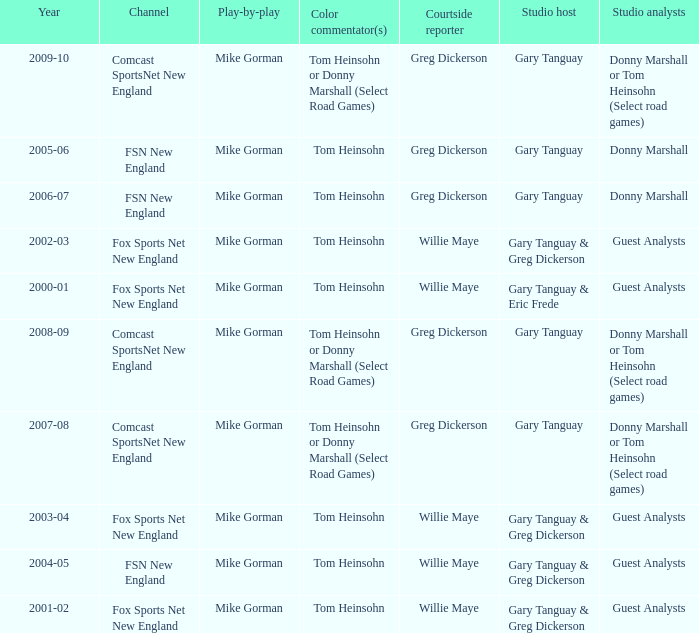WHich Color commentatorhas a Studio host of gary tanguay & eric frede? Tom Heinsohn. 